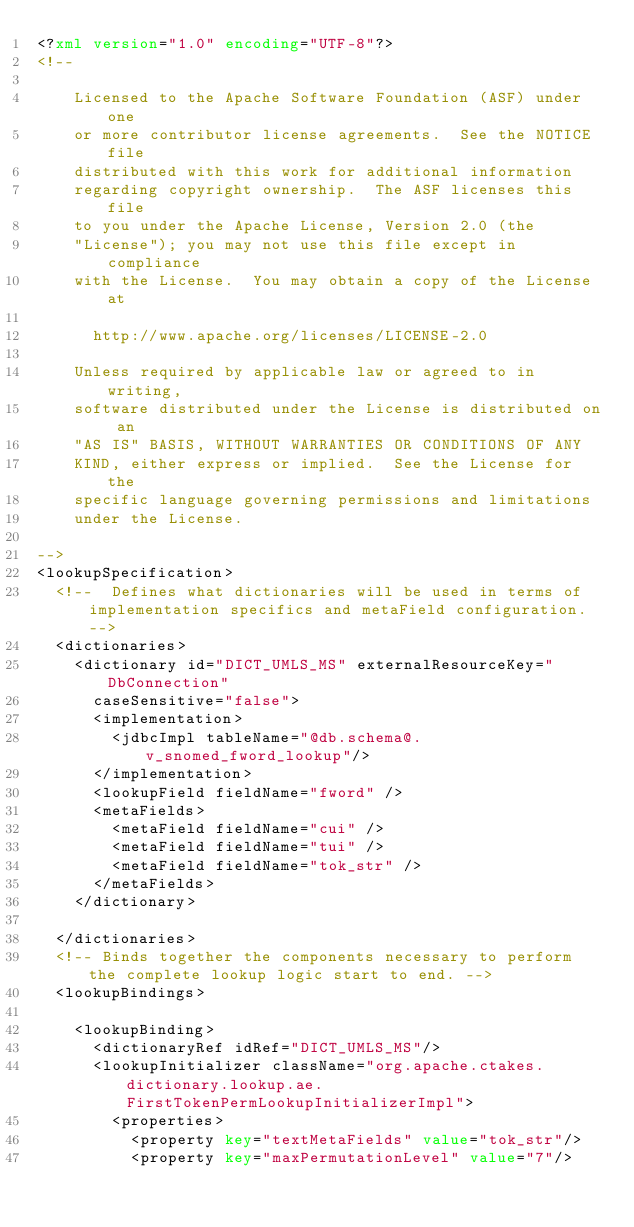<code> <loc_0><loc_0><loc_500><loc_500><_XML_><?xml version="1.0" encoding="UTF-8"?>
<!--

    Licensed to the Apache Software Foundation (ASF) under one
    or more contributor license agreements.  See the NOTICE file
    distributed with this work for additional information
    regarding copyright ownership.  The ASF licenses this file
    to you under the Apache License, Version 2.0 (the
    "License"); you may not use this file except in compliance
    with the License.  You may obtain a copy of the License at

      http://www.apache.org/licenses/LICENSE-2.0

    Unless required by applicable law or agreed to in writing,
    software distributed under the License is distributed on an
    "AS IS" BASIS, WITHOUT WARRANTIES OR CONDITIONS OF ANY
    KIND, either express or implied.  See the License for the
    specific language governing permissions and limitations
    under the License.

-->
<lookupSpecification>
	<!--  Defines what dictionaries will be used in terms of implementation specifics and metaField configuration. -->
	<dictionaries>
		<dictionary id="DICT_UMLS_MS" externalResourceKey="DbConnection"
			caseSensitive="false">
			<implementation>
				<jdbcImpl tableName="@db.schema@.v_snomed_fword_lookup"/>
			</implementation>
			<lookupField fieldName="fword" />
			<metaFields>
				<metaField fieldName="cui" />
				<metaField fieldName="tui" />
				<metaField fieldName="tok_str" />
			</metaFields>
		</dictionary>	
	
	</dictionaries>
	<!-- Binds together the components necessary to perform the complete lookup logic start to end. -->
	<lookupBindings>
	
		<lookupBinding>
			<dictionaryRef idRef="DICT_UMLS_MS"/>
			<lookupInitializer className="org.apache.ctakes.dictionary.lookup.ae.FirstTokenPermLookupInitializerImpl">
				<properties>
					<property key="textMetaFields" value="tok_str"/>
					<property key="maxPermutationLevel" value="7"/></code> 